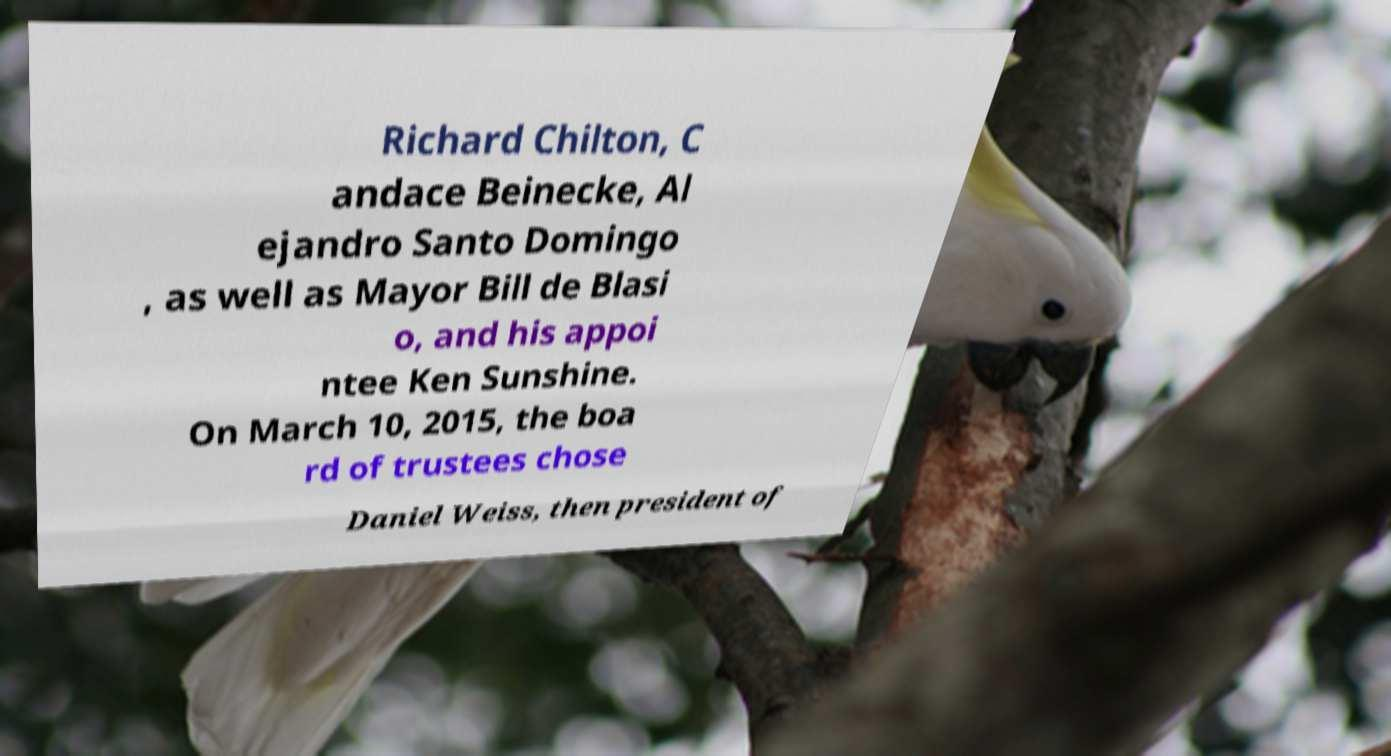Can you read and provide the text displayed in the image?This photo seems to have some interesting text. Can you extract and type it out for me? Richard Chilton, C andace Beinecke, Al ejandro Santo Domingo , as well as Mayor Bill de Blasi o, and his appoi ntee Ken Sunshine. On March 10, 2015, the boa rd of trustees chose Daniel Weiss, then president of 